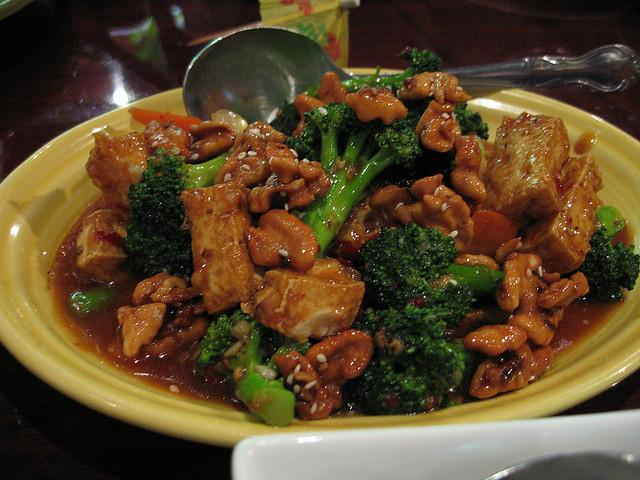What is the food covered in to make it orange?

Choices:
A) spit
B) gasoline
C) sauce
D) soda sauce 